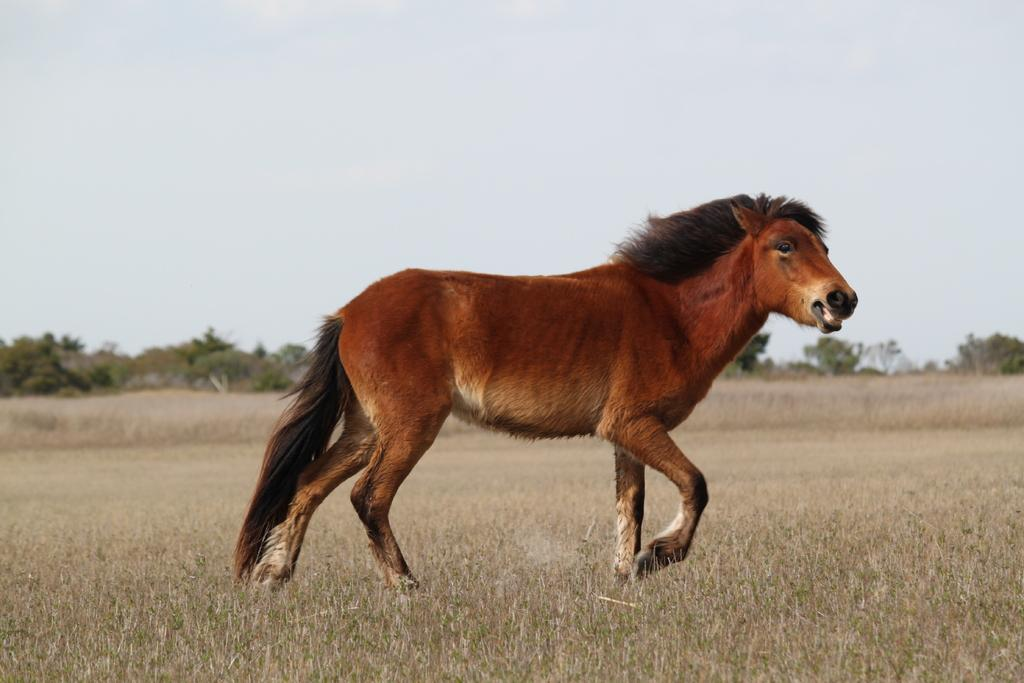What is the main subject of the picture? The main subject of the picture is a horse. Where is the picture taken? The picture is taken in a field. What can be seen in the background of the image? There are trees in the background of the image. What is the weather like in the picture? It is sunny and the sky is clear. What type of event is happening in the field with the horse and popcorn? There is no popcorn present in the image, and no event is taking place. 